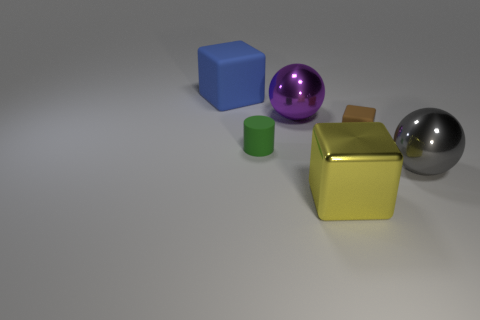How many purple objects are there?
Your answer should be compact. 1. There is a metal thing that is in front of the tiny matte cylinder and to the left of the small brown object; what shape is it?
Your response must be concise. Cube. There is a rubber block that is to the right of the blue thing; is its color the same as the metal thing behind the gray thing?
Provide a succinct answer. No. Are there any other cubes made of the same material as the big yellow cube?
Your answer should be compact. No. Is the number of shiny things in front of the large blue cube the same as the number of balls left of the big gray shiny thing?
Provide a succinct answer. No. What is the size of the thing that is on the left side of the green matte cylinder?
Ensure brevity in your answer.  Large. What material is the large cube that is right of the large block that is behind the big metallic block?
Your answer should be very brief. Metal. How many yellow blocks are behind the large cube that is behind the metallic sphere that is right of the big yellow cube?
Provide a short and direct response. 0. Is the material of the thing behind the big purple object the same as the small thing that is on the right side of the green matte object?
Your answer should be compact. Yes. How many large gray objects are the same shape as the brown rubber object?
Your answer should be very brief. 0. 